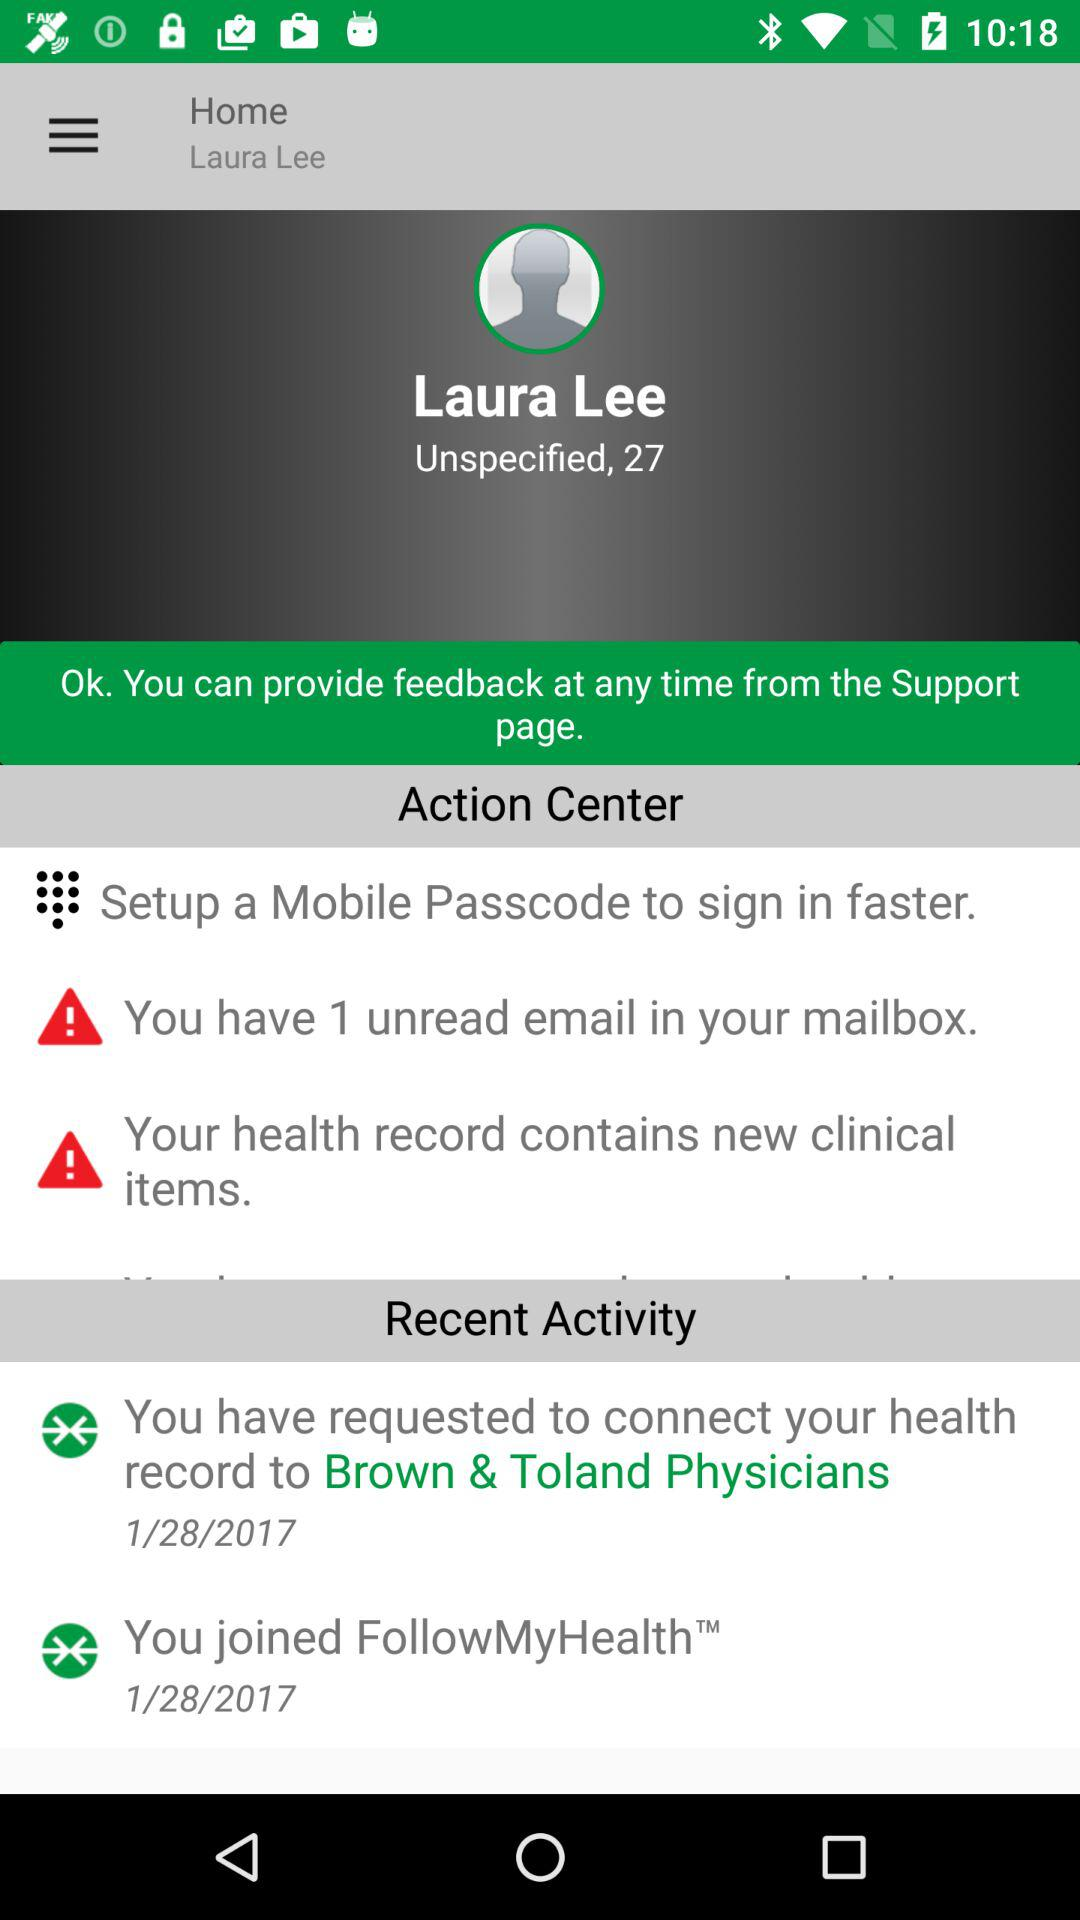How many unread emails does Laura Lee have?
Answer the question using a single word or phrase. 1 